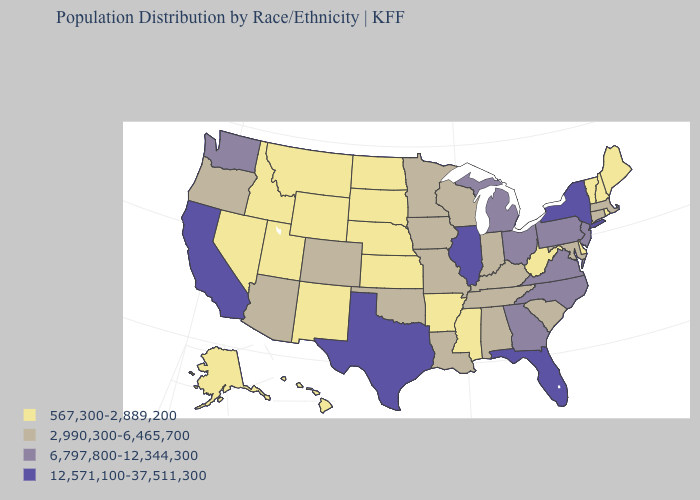What is the value of Pennsylvania?
Be succinct. 6,797,800-12,344,300. Which states have the highest value in the USA?
Answer briefly. California, Florida, Illinois, New York, Texas. Name the states that have a value in the range 567,300-2,889,200?
Give a very brief answer. Alaska, Arkansas, Delaware, Hawaii, Idaho, Kansas, Maine, Mississippi, Montana, Nebraska, Nevada, New Hampshire, New Mexico, North Dakota, Rhode Island, South Dakota, Utah, Vermont, West Virginia, Wyoming. What is the lowest value in the MidWest?
Concise answer only. 567,300-2,889,200. Name the states that have a value in the range 567,300-2,889,200?
Answer briefly. Alaska, Arkansas, Delaware, Hawaii, Idaho, Kansas, Maine, Mississippi, Montana, Nebraska, Nevada, New Hampshire, New Mexico, North Dakota, Rhode Island, South Dakota, Utah, Vermont, West Virginia, Wyoming. What is the highest value in the USA?
Give a very brief answer. 12,571,100-37,511,300. Name the states that have a value in the range 12,571,100-37,511,300?
Give a very brief answer. California, Florida, Illinois, New York, Texas. Among the states that border Kentucky , does Virginia have the highest value?
Be succinct. No. Among the states that border Missouri , which have the lowest value?
Concise answer only. Arkansas, Kansas, Nebraska. How many symbols are there in the legend?
Short answer required. 4. Does Massachusetts have a higher value than New Hampshire?
Quick response, please. Yes. Among the states that border Connecticut , does New York have the lowest value?
Be succinct. No. Name the states that have a value in the range 567,300-2,889,200?
Short answer required. Alaska, Arkansas, Delaware, Hawaii, Idaho, Kansas, Maine, Mississippi, Montana, Nebraska, Nevada, New Hampshire, New Mexico, North Dakota, Rhode Island, South Dakota, Utah, Vermont, West Virginia, Wyoming. 